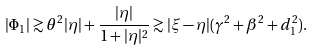Convert formula to latex. <formula><loc_0><loc_0><loc_500><loc_500>| \Phi _ { 1 } | \gtrsim \theta ^ { 2 } | \eta | + \frac { | \eta | } { 1 + | \eta | ^ { 2 } } \gtrsim | \xi - \eta | ( \gamma ^ { 2 } + \beta ^ { 2 } + d _ { 1 } ^ { 2 } ) .</formula> 